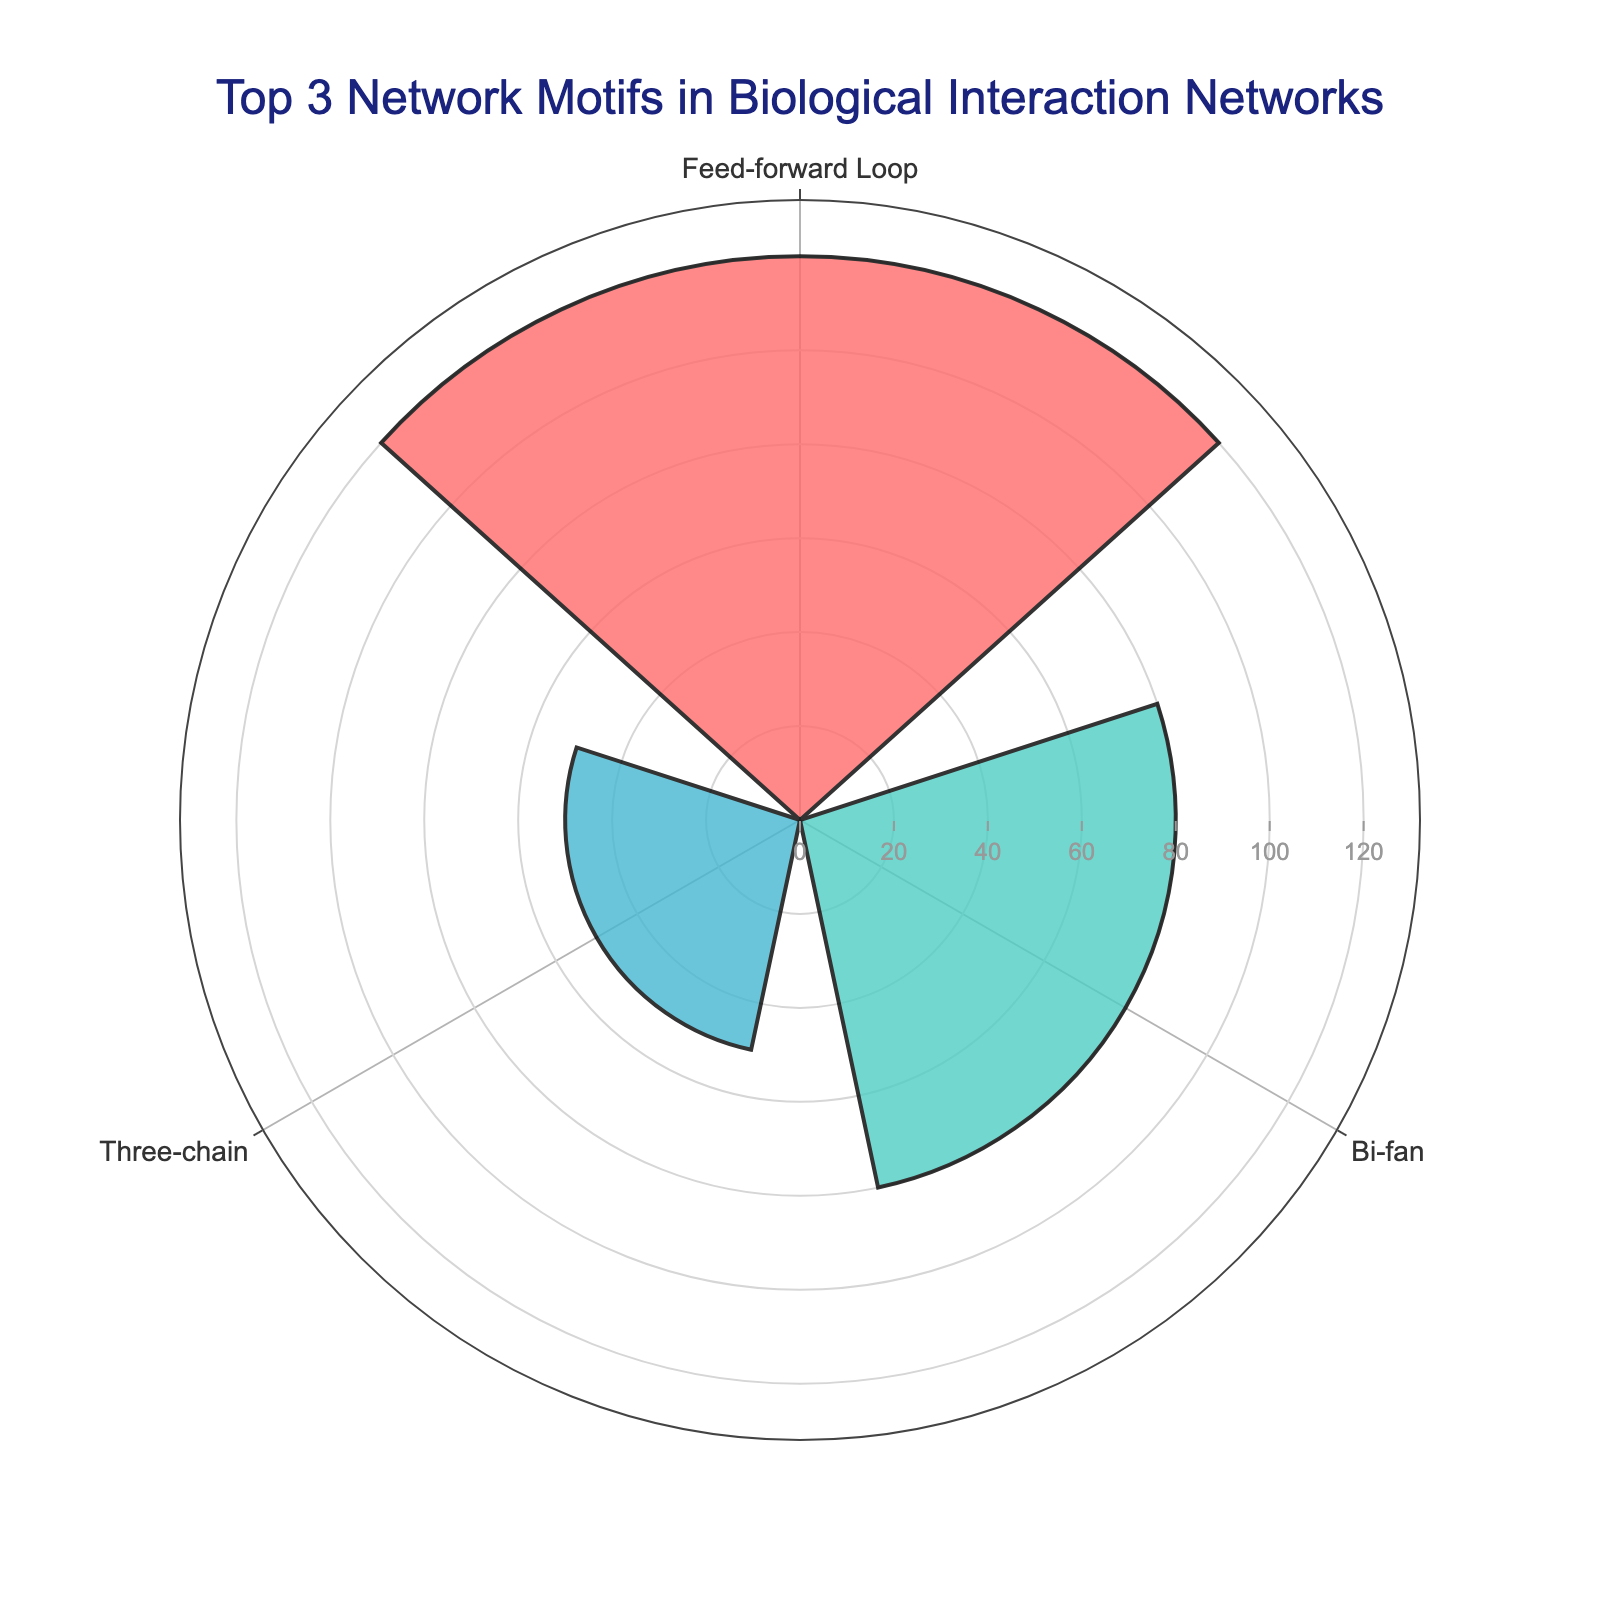What's the title of the figure? The title is displayed at the top center of the chart and reads: "Top 3 Network Motifs in Biological Interaction Networks"
Answer: Top 3 Network Motifs in Biological Interaction Networks How many motifs are represented in the rose chart? By counting the distinct segments in the rose chart, we see three different motifs are shown.
Answer: Three Which motif type occurs most frequently? Observing the radial length of the bars, the "Feed-forward Loop" has the longest bar, indicating the most occurrences.
Answer: Feed-forward Loop What is the occurrence value for the "Three-chain" motif? The bar labeled "Three-chain" reaches a radial axis value of 50.
Answer: 50 Compare the occurrences of the "Feed-forward Loop" and "Bi-fan" motifs. Which one is higher and by how much? The "Feed-forward Loop" bar extends to 120, while the "Bi-fan" bar reaches 80. 120 - 80 equals 40.
Answer: Feed-forward Loop by 40 What is the combined occurrence count of the top 3 motif types displayed? Summing the radial values of the three bars: 120 (Feed-forward Loop) + 80 (Bi-fan) + 50 (Three-chain) equals 250.
Answer: 250 Which motif type has the fewest occurrences, and what is its value? Among the displayed bars, the "Three-chain" motif has the shortest bar, indicating the fewest occurrences at 50.
Answer: Three-chain with 50 Identify the color associated with the "Bi-fan" motif. The color of the "Bi-fan" bar in the chart can be distinctly observed. It is a teal or light cyan shade.
Answer: Teal or light cyan By what percentage do the "Bi-fan" occurrences exceed the "Three-chain" occurrences? Calculate the difference and then the percentage: (80 - 50) / 50 * 100 = 60%.
Answer: 60% If the chart were to include the "Single-input Module" motif, would its bar be longer or shorter than the "Three-chain" bar? Considering the value for "Single-input Module" is 30, which is less than the "Three-chain" value of 50, its bar would be shorter.
Answer: Shorter 